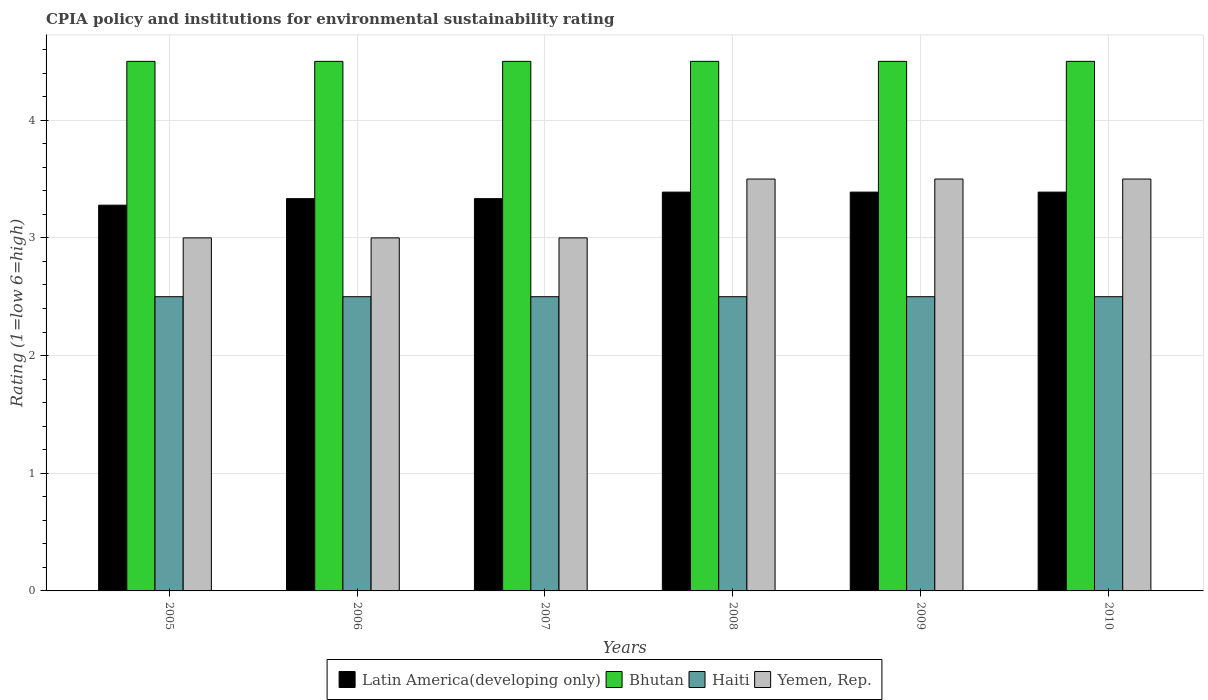How many groups of bars are there?
Provide a succinct answer. 6. Are the number of bars per tick equal to the number of legend labels?
Provide a succinct answer. Yes. Are the number of bars on each tick of the X-axis equal?
Your answer should be compact. Yes. How many bars are there on the 5th tick from the left?
Ensure brevity in your answer.  4. What is the label of the 6th group of bars from the left?
Ensure brevity in your answer.  2010. Across all years, what is the minimum CPIA rating in Latin America(developing only)?
Keep it short and to the point. 3.28. In which year was the CPIA rating in Haiti minimum?
Offer a terse response. 2005. What is the total CPIA rating in Latin America(developing only) in the graph?
Offer a very short reply. 20.11. What is the difference between the CPIA rating in Latin America(developing only) in 2005 and the CPIA rating in Bhutan in 2006?
Provide a short and direct response. -1.22. Is the CPIA rating in Yemen, Rep. in 2005 less than that in 2006?
Make the answer very short. No. Is the difference between the CPIA rating in Yemen, Rep. in 2006 and 2009 greater than the difference between the CPIA rating in Bhutan in 2006 and 2009?
Offer a terse response. No. What is the difference between the highest and the lowest CPIA rating in Latin America(developing only)?
Your answer should be compact. 0.11. Is the sum of the CPIA rating in Haiti in 2006 and 2009 greater than the maximum CPIA rating in Bhutan across all years?
Your response must be concise. Yes. Is it the case that in every year, the sum of the CPIA rating in Latin America(developing only) and CPIA rating in Bhutan is greater than the sum of CPIA rating in Yemen, Rep. and CPIA rating in Haiti?
Your answer should be very brief. No. What does the 2nd bar from the left in 2007 represents?
Provide a short and direct response. Bhutan. What does the 2nd bar from the right in 2010 represents?
Your response must be concise. Haiti. How many bars are there?
Ensure brevity in your answer.  24. How many years are there in the graph?
Give a very brief answer. 6. What is the difference between two consecutive major ticks on the Y-axis?
Provide a succinct answer. 1. Where does the legend appear in the graph?
Your response must be concise. Bottom center. How many legend labels are there?
Keep it short and to the point. 4. How are the legend labels stacked?
Make the answer very short. Horizontal. What is the title of the graph?
Make the answer very short. CPIA policy and institutions for environmental sustainability rating. What is the Rating (1=low 6=high) in Latin America(developing only) in 2005?
Give a very brief answer. 3.28. What is the Rating (1=low 6=high) of Yemen, Rep. in 2005?
Provide a short and direct response. 3. What is the Rating (1=low 6=high) in Latin America(developing only) in 2006?
Provide a short and direct response. 3.33. What is the Rating (1=low 6=high) of Haiti in 2006?
Your response must be concise. 2.5. What is the Rating (1=low 6=high) of Latin America(developing only) in 2007?
Keep it short and to the point. 3.33. What is the Rating (1=low 6=high) in Haiti in 2007?
Offer a very short reply. 2.5. What is the Rating (1=low 6=high) in Yemen, Rep. in 2007?
Your answer should be compact. 3. What is the Rating (1=low 6=high) of Latin America(developing only) in 2008?
Provide a succinct answer. 3.39. What is the Rating (1=low 6=high) in Bhutan in 2008?
Offer a terse response. 4.5. What is the Rating (1=low 6=high) of Latin America(developing only) in 2009?
Ensure brevity in your answer.  3.39. What is the Rating (1=low 6=high) in Latin America(developing only) in 2010?
Your response must be concise. 3.39. What is the Rating (1=low 6=high) in Bhutan in 2010?
Offer a very short reply. 4.5. Across all years, what is the maximum Rating (1=low 6=high) in Latin America(developing only)?
Your answer should be very brief. 3.39. Across all years, what is the minimum Rating (1=low 6=high) in Latin America(developing only)?
Keep it short and to the point. 3.28. Across all years, what is the minimum Rating (1=low 6=high) of Bhutan?
Offer a very short reply. 4.5. Across all years, what is the minimum Rating (1=low 6=high) of Haiti?
Provide a short and direct response. 2.5. What is the total Rating (1=low 6=high) of Latin America(developing only) in the graph?
Give a very brief answer. 20.11. What is the difference between the Rating (1=low 6=high) in Latin America(developing only) in 2005 and that in 2006?
Provide a succinct answer. -0.06. What is the difference between the Rating (1=low 6=high) in Latin America(developing only) in 2005 and that in 2007?
Ensure brevity in your answer.  -0.06. What is the difference between the Rating (1=low 6=high) of Bhutan in 2005 and that in 2007?
Offer a terse response. 0. What is the difference between the Rating (1=low 6=high) in Haiti in 2005 and that in 2007?
Your response must be concise. 0. What is the difference between the Rating (1=low 6=high) of Latin America(developing only) in 2005 and that in 2008?
Your answer should be compact. -0.11. What is the difference between the Rating (1=low 6=high) of Yemen, Rep. in 2005 and that in 2008?
Offer a terse response. -0.5. What is the difference between the Rating (1=low 6=high) in Latin America(developing only) in 2005 and that in 2009?
Your answer should be very brief. -0.11. What is the difference between the Rating (1=low 6=high) of Bhutan in 2005 and that in 2009?
Make the answer very short. 0. What is the difference between the Rating (1=low 6=high) of Haiti in 2005 and that in 2009?
Offer a very short reply. 0. What is the difference between the Rating (1=low 6=high) of Yemen, Rep. in 2005 and that in 2009?
Keep it short and to the point. -0.5. What is the difference between the Rating (1=low 6=high) of Latin America(developing only) in 2005 and that in 2010?
Your response must be concise. -0.11. What is the difference between the Rating (1=low 6=high) of Bhutan in 2005 and that in 2010?
Provide a succinct answer. 0. What is the difference between the Rating (1=low 6=high) in Yemen, Rep. in 2005 and that in 2010?
Provide a short and direct response. -0.5. What is the difference between the Rating (1=low 6=high) of Bhutan in 2006 and that in 2007?
Keep it short and to the point. 0. What is the difference between the Rating (1=low 6=high) of Yemen, Rep. in 2006 and that in 2007?
Provide a succinct answer. 0. What is the difference between the Rating (1=low 6=high) in Latin America(developing only) in 2006 and that in 2008?
Provide a succinct answer. -0.06. What is the difference between the Rating (1=low 6=high) of Yemen, Rep. in 2006 and that in 2008?
Offer a terse response. -0.5. What is the difference between the Rating (1=low 6=high) in Latin America(developing only) in 2006 and that in 2009?
Provide a short and direct response. -0.06. What is the difference between the Rating (1=low 6=high) of Bhutan in 2006 and that in 2009?
Your answer should be compact. 0. What is the difference between the Rating (1=low 6=high) of Haiti in 2006 and that in 2009?
Ensure brevity in your answer.  0. What is the difference between the Rating (1=low 6=high) of Yemen, Rep. in 2006 and that in 2009?
Offer a terse response. -0.5. What is the difference between the Rating (1=low 6=high) in Latin America(developing only) in 2006 and that in 2010?
Offer a very short reply. -0.06. What is the difference between the Rating (1=low 6=high) in Haiti in 2006 and that in 2010?
Your answer should be very brief. 0. What is the difference between the Rating (1=low 6=high) in Latin America(developing only) in 2007 and that in 2008?
Provide a succinct answer. -0.06. What is the difference between the Rating (1=low 6=high) of Bhutan in 2007 and that in 2008?
Provide a succinct answer. 0. What is the difference between the Rating (1=low 6=high) in Haiti in 2007 and that in 2008?
Keep it short and to the point. 0. What is the difference between the Rating (1=low 6=high) in Yemen, Rep. in 2007 and that in 2008?
Ensure brevity in your answer.  -0.5. What is the difference between the Rating (1=low 6=high) of Latin America(developing only) in 2007 and that in 2009?
Make the answer very short. -0.06. What is the difference between the Rating (1=low 6=high) in Haiti in 2007 and that in 2009?
Give a very brief answer. 0. What is the difference between the Rating (1=low 6=high) in Latin America(developing only) in 2007 and that in 2010?
Keep it short and to the point. -0.06. What is the difference between the Rating (1=low 6=high) in Bhutan in 2007 and that in 2010?
Your response must be concise. 0. What is the difference between the Rating (1=low 6=high) in Latin America(developing only) in 2008 and that in 2010?
Keep it short and to the point. 0. What is the difference between the Rating (1=low 6=high) of Bhutan in 2008 and that in 2010?
Provide a succinct answer. 0. What is the difference between the Rating (1=low 6=high) in Haiti in 2008 and that in 2010?
Keep it short and to the point. 0. What is the difference between the Rating (1=low 6=high) of Yemen, Rep. in 2008 and that in 2010?
Keep it short and to the point. 0. What is the difference between the Rating (1=low 6=high) in Latin America(developing only) in 2009 and that in 2010?
Your answer should be compact. 0. What is the difference between the Rating (1=low 6=high) in Haiti in 2009 and that in 2010?
Give a very brief answer. 0. What is the difference between the Rating (1=low 6=high) in Latin America(developing only) in 2005 and the Rating (1=low 6=high) in Bhutan in 2006?
Ensure brevity in your answer.  -1.22. What is the difference between the Rating (1=low 6=high) in Latin America(developing only) in 2005 and the Rating (1=low 6=high) in Haiti in 2006?
Give a very brief answer. 0.78. What is the difference between the Rating (1=low 6=high) in Latin America(developing only) in 2005 and the Rating (1=low 6=high) in Yemen, Rep. in 2006?
Make the answer very short. 0.28. What is the difference between the Rating (1=low 6=high) in Bhutan in 2005 and the Rating (1=low 6=high) in Haiti in 2006?
Your answer should be compact. 2. What is the difference between the Rating (1=low 6=high) in Haiti in 2005 and the Rating (1=low 6=high) in Yemen, Rep. in 2006?
Your answer should be compact. -0.5. What is the difference between the Rating (1=low 6=high) in Latin America(developing only) in 2005 and the Rating (1=low 6=high) in Bhutan in 2007?
Ensure brevity in your answer.  -1.22. What is the difference between the Rating (1=low 6=high) of Latin America(developing only) in 2005 and the Rating (1=low 6=high) of Haiti in 2007?
Your response must be concise. 0.78. What is the difference between the Rating (1=low 6=high) in Latin America(developing only) in 2005 and the Rating (1=low 6=high) in Yemen, Rep. in 2007?
Your answer should be compact. 0.28. What is the difference between the Rating (1=low 6=high) of Bhutan in 2005 and the Rating (1=low 6=high) of Haiti in 2007?
Provide a short and direct response. 2. What is the difference between the Rating (1=low 6=high) in Haiti in 2005 and the Rating (1=low 6=high) in Yemen, Rep. in 2007?
Your answer should be very brief. -0.5. What is the difference between the Rating (1=low 6=high) of Latin America(developing only) in 2005 and the Rating (1=low 6=high) of Bhutan in 2008?
Keep it short and to the point. -1.22. What is the difference between the Rating (1=low 6=high) in Latin America(developing only) in 2005 and the Rating (1=low 6=high) in Haiti in 2008?
Your answer should be very brief. 0.78. What is the difference between the Rating (1=low 6=high) in Latin America(developing only) in 2005 and the Rating (1=low 6=high) in Yemen, Rep. in 2008?
Your answer should be compact. -0.22. What is the difference between the Rating (1=low 6=high) in Bhutan in 2005 and the Rating (1=low 6=high) in Haiti in 2008?
Provide a short and direct response. 2. What is the difference between the Rating (1=low 6=high) in Latin America(developing only) in 2005 and the Rating (1=low 6=high) in Bhutan in 2009?
Ensure brevity in your answer.  -1.22. What is the difference between the Rating (1=low 6=high) of Latin America(developing only) in 2005 and the Rating (1=low 6=high) of Haiti in 2009?
Ensure brevity in your answer.  0.78. What is the difference between the Rating (1=low 6=high) of Latin America(developing only) in 2005 and the Rating (1=low 6=high) of Yemen, Rep. in 2009?
Your answer should be compact. -0.22. What is the difference between the Rating (1=low 6=high) in Bhutan in 2005 and the Rating (1=low 6=high) in Haiti in 2009?
Your answer should be compact. 2. What is the difference between the Rating (1=low 6=high) in Latin America(developing only) in 2005 and the Rating (1=low 6=high) in Bhutan in 2010?
Provide a succinct answer. -1.22. What is the difference between the Rating (1=low 6=high) in Latin America(developing only) in 2005 and the Rating (1=low 6=high) in Yemen, Rep. in 2010?
Ensure brevity in your answer.  -0.22. What is the difference between the Rating (1=low 6=high) of Bhutan in 2005 and the Rating (1=low 6=high) of Yemen, Rep. in 2010?
Make the answer very short. 1. What is the difference between the Rating (1=low 6=high) in Haiti in 2005 and the Rating (1=low 6=high) in Yemen, Rep. in 2010?
Offer a very short reply. -1. What is the difference between the Rating (1=low 6=high) in Latin America(developing only) in 2006 and the Rating (1=low 6=high) in Bhutan in 2007?
Your answer should be compact. -1.17. What is the difference between the Rating (1=low 6=high) in Latin America(developing only) in 2006 and the Rating (1=low 6=high) in Yemen, Rep. in 2007?
Make the answer very short. 0.33. What is the difference between the Rating (1=low 6=high) of Bhutan in 2006 and the Rating (1=low 6=high) of Haiti in 2007?
Your answer should be very brief. 2. What is the difference between the Rating (1=low 6=high) of Bhutan in 2006 and the Rating (1=low 6=high) of Yemen, Rep. in 2007?
Provide a short and direct response. 1.5. What is the difference between the Rating (1=low 6=high) of Haiti in 2006 and the Rating (1=low 6=high) of Yemen, Rep. in 2007?
Offer a very short reply. -0.5. What is the difference between the Rating (1=low 6=high) in Latin America(developing only) in 2006 and the Rating (1=low 6=high) in Bhutan in 2008?
Offer a terse response. -1.17. What is the difference between the Rating (1=low 6=high) of Latin America(developing only) in 2006 and the Rating (1=low 6=high) of Haiti in 2008?
Give a very brief answer. 0.83. What is the difference between the Rating (1=low 6=high) of Latin America(developing only) in 2006 and the Rating (1=low 6=high) of Yemen, Rep. in 2008?
Ensure brevity in your answer.  -0.17. What is the difference between the Rating (1=low 6=high) of Bhutan in 2006 and the Rating (1=low 6=high) of Yemen, Rep. in 2008?
Your answer should be compact. 1. What is the difference between the Rating (1=low 6=high) in Haiti in 2006 and the Rating (1=low 6=high) in Yemen, Rep. in 2008?
Offer a very short reply. -1. What is the difference between the Rating (1=low 6=high) in Latin America(developing only) in 2006 and the Rating (1=low 6=high) in Bhutan in 2009?
Make the answer very short. -1.17. What is the difference between the Rating (1=low 6=high) of Latin America(developing only) in 2006 and the Rating (1=low 6=high) of Yemen, Rep. in 2009?
Offer a very short reply. -0.17. What is the difference between the Rating (1=low 6=high) in Bhutan in 2006 and the Rating (1=low 6=high) in Haiti in 2009?
Provide a short and direct response. 2. What is the difference between the Rating (1=low 6=high) of Bhutan in 2006 and the Rating (1=low 6=high) of Yemen, Rep. in 2009?
Make the answer very short. 1. What is the difference between the Rating (1=low 6=high) in Latin America(developing only) in 2006 and the Rating (1=low 6=high) in Bhutan in 2010?
Offer a very short reply. -1.17. What is the difference between the Rating (1=low 6=high) in Latin America(developing only) in 2006 and the Rating (1=low 6=high) in Haiti in 2010?
Keep it short and to the point. 0.83. What is the difference between the Rating (1=low 6=high) of Latin America(developing only) in 2007 and the Rating (1=low 6=high) of Bhutan in 2008?
Make the answer very short. -1.17. What is the difference between the Rating (1=low 6=high) in Latin America(developing only) in 2007 and the Rating (1=low 6=high) in Yemen, Rep. in 2008?
Make the answer very short. -0.17. What is the difference between the Rating (1=low 6=high) of Haiti in 2007 and the Rating (1=low 6=high) of Yemen, Rep. in 2008?
Provide a succinct answer. -1. What is the difference between the Rating (1=low 6=high) in Latin America(developing only) in 2007 and the Rating (1=low 6=high) in Bhutan in 2009?
Your answer should be compact. -1.17. What is the difference between the Rating (1=low 6=high) in Latin America(developing only) in 2007 and the Rating (1=low 6=high) in Haiti in 2009?
Offer a very short reply. 0.83. What is the difference between the Rating (1=low 6=high) in Latin America(developing only) in 2007 and the Rating (1=low 6=high) in Yemen, Rep. in 2009?
Your answer should be very brief. -0.17. What is the difference between the Rating (1=low 6=high) of Bhutan in 2007 and the Rating (1=low 6=high) of Yemen, Rep. in 2009?
Ensure brevity in your answer.  1. What is the difference between the Rating (1=low 6=high) of Haiti in 2007 and the Rating (1=low 6=high) of Yemen, Rep. in 2009?
Your answer should be compact. -1. What is the difference between the Rating (1=low 6=high) in Latin America(developing only) in 2007 and the Rating (1=low 6=high) in Bhutan in 2010?
Provide a short and direct response. -1.17. What is the difference between the Rating (1=low 6=high) of Latin America(developing only) in 2007 and the Rating (1=low 6=high) of Haiti in 2010?
Offer a very short reply. 0.83. What is the difference between the Rating (1=low 6=high) in Latin America(developing only) in 2007 and the Rating (1=low 6=high) in Yemen, Rep. in 2010?
Ensure brevity in your answer.  -0.17. What is the difference between the Rating (1=low 6=high) in Bhutan in 2007 and the Rating (1=low 6=high) in Haiti in 2010?
Your answer should be very brief. 2. What is the difference between the Rating (1=low 6=high) of Latin America(developing only) in 2008 and the Rating (1=low 6=high) of Bhutan in 2009?
Offer a very short reply. -1.11. What is the difference between the Rating (1=low 6=high) in Latin America(developing only) in 2008 and the Rating (1=low 6=high) in Haiti in 2009?
Make the answer very short. 0.89. What is the difference between the Rating (1=low 6=high) in Latin America(developing only) in 2008 and the Rating (1=low 6=high) in Yemen, Rep. in 2009?
Make the answer very short. -0.11. What is the difference between the Rating (1=low 6=high) in Bhutan in 2008 and the Rating (1=low 6=high) in Haiti in 2009?
Ensure brevity in your answer.  2. What is the difference between the Rating (1=low 6=high) of Latin America(developing only) in 2008 and the Rating (1=low 6=high) of Bhutan in 2010?
Provide a succinct answer. -1.11. What is the difference between the Rating (1=low 6=high) in Latin America(developing only) in 2008 and the Rating (1=low 6=high) in Yemen, Rep. in 2010?
Your answer should be compact. -0.11. What is the difference between the Rating (1=low 6=high) in Bhutan in 2008 and the Rating (1=low 6=high) in Haiti in 2010?
Give a very brief answer. 2. What is the difference between the Rating (1=low 6=high) in Bhutan in 2008 and the Rating (1=low 6=high) in Yemen, Rep. in 2010?
Ensure brevity in your answer.  1. What is the difference between the Rating (1=low 6=high) of Haiti in 2008 and the Rating (1=low 6=high) of Yemen, Rep. in 2010?
Offer a very short reply. -1. What is the difference between the Rating (1=low 6=high) of Latin America(developing only) in 2009 and the Rating (1=low 6=high) of Bhutan in 2010?
Your answer should be compact. -1.11. What is the difference between the Rating (1=low 6=high) in Latin America(developing only) in 2009 and the Rating (1=low 6=high) in Haiti in 2010?
Your answer should be very brief. 0.89. What is the difference between the Rating (1=low 6=high) in Latin America(developing only) in 2009 and the Rating (1=low 6=high) in Yemen, Rep. in 2010?
Your response must be concise. -0.11. What is the difference between the Rating (1=low 6=high) in Bhutan in 2009 and the Rating (1=low 6=high) in Haiti in 2010?
Give a very brief answer. 2. What is the difference between the Rating (1=low 6=high) of Bhutan in 2009 and the Rating (1=low 6=high) of Yemen, Rep. in 2010?
Offer a terse response. 1. What is the average Rating (1=low 6=high) in Latin America(developing only) per year?
Keep it short and to the point. 3.35. What is the average Rating (1=low 6=high) in Yemen, Rep. per year?
Offer a very short reply. 3.25. In the year 2005, what is the difference between the Rating (1=low 6=high) of Latin America(developing only) and Rating (1=low 6=high) of Bhutan?
Ensure brevity in your answer.  -1.22. In the year 2005, what is the difference between the Rating (1=low 6=high) in Latin America(developing only) and Rating (1=low 6=high) in Haiti?
Your response must be concise. 0.78. In the year 2005, what is the difference between the Rating (1=low 6=high) in Latin America(developing only) and Rating (1=low 6=high) in Yemen, Rep.?
Your answer should be compact. 0.28. In the year 2005, what is the difference between the Rating (1=low 6=high) of Bhutan and Rating (1=low 6=high) of Haiti?
Offer a very short reply. 2. In the year 2005, what is the difference between the Rating (1=low 6=high) of Bhutan and Rating (1=low 6=high) of Yemen, Rep.?
Keep it short and to the point. 1.5. In the year 2006, what is the difference between the Rating (1=low 6=high) of Latin America(developing only) and Rating (1=low 6=high) of Bhutan?
Your response must be concise. -1.17. In the year 2006, what is the difference between the Rating (1=low 6=high) of Latin America(developing only) and Rating (1=low 6=high) of Haiti?
Make the answer very short. 0.83. In the year 2006, what is the difference between the Rating (1=low 6=high) in Bhutan and Rating (1=low 6=high) in Yemen, Rep.?
Keep it short and to the point. 1.5. In the year 2007, what is the difference between the Rating (1=low 6=high) of Latin America(developing only) and Rating (1=low 6=high) of Bhutan?
Offer a terse response. -1.17. In the year 2007, what is the difference between the Rating (1=low 6=high) in Bhutan and Rating (1=low 6=high) in Yemen, Rep.?
Make the answer very short. 1.5. In the year 2008, what is the difference between the Rating (1=low 6=high) in Latin America(developing only) and Rating (1=low 6=high) in Bhutan?
Provide a succinct answer. -1.11. In the year 2008, what is the difference between the Rating (1=low 6=high) of Latin America(developing only) and Rating (1=low 6=high) of Haiti?
Your answer should be compact. 0.89. In the year 2008, what is the difference between the Rating (1=low 6=high) of Latin America(developing only) and Rating (1=low 6=high) of Yemen, Rep.?
Make the answer very short. -0.11. In the year 2008, what is the difference between the Rating (1=low 6=high) of Bhutan and Rating (1=low 6=high) of Haiti?
Make the answer very short. 2. In the year 2008, what is the difference between the Rating (1=low 6=high) in Haiti and Rating (1=low 6=high) in Yemen, Rep.?
Make the answer very short. -1. In the year 2009, what is the difference between the Rating (1=low 6=high) in Latin America(developing only) and Rating (1=low 6=high) in Bhutan?
Provide a short and direct response. -1.11. In the year 2009, what is the difference between the Rating (1=low 6=high) in Latin America(developing only) and Rating (1=low 6=high) in Haiti?
Offer a terse response. 0.89. In the year 2009, what is the difference between the Rating (1=low 6=high) of Latin America(developing only) and Rating (1=low 6=high) of Yemen, Rep.?
Offer a terse response. -0.11. In the year 2009, what is the difference between the Rating (1=low 6=high) in Bhutan and Rating (1=low 6=high) in Haiti?
Give a very brief answer. 2. In the year 2009, what is the difference between the Rating (1=low 6=high) of Bhutan and Rating (1=low 6=high) of Yemen, Rep.?
Provide a short and direct response. 1. In the year 2009, what is the difference between the Rating (1=low 6=high) of Haiti and Rating (1=low 6=high) of Yemen, Rep.?
Provide a short and direct response. -1. In the year 2010, what is the difference between the Rating (1=low 6=high) of Latin America(developing only) and Rating (1=low 6=high) of Bhutan?
Your answer should be compact. -1.11. In the year 2010, what is the difference between the Rating (1=low 6=high) in Latin America(developing only) and Rating (1=low 6=high) in Haiti?
Your answer should be compact. 0.89. In the year 2010, what is the difference between the Rating (1=low 6=high) of Latin America(developing only) and Rating (1=low 6=high) of Yemen, Rep.?
Make the answer very short. -0.11. In the year 2010, what is the difference between the Rating (1=low 6=high) of Bhutan and Rating (1=low 6=high) of Yemen, Rep.?
Ensure brevity in your answer.  1. What is the ratio of the Rating (1=low 6=high) of Latin America(developing only) in 2005 to that in 2006?
Your response must be concise. 0.98. What is the ratio of the Rating (1=low 6=high) of Latin America(developing only) in 2005 to that in 2007?
Ensure brevity in your answer.  0.98. What is the ratio of the Rating (1=low 6=high) in Bhutan in 2005 to that in 2007?
Make the answer very short. 1. What is the ratio of the Rating (1=low 6=high) of Haiti in 2005 to that in 2007?
Keep it short and to the point. 1. What is the ratio of the Rating (1=low 6=high) of Latin America(developing only) in 2005 to that in 2008?
Offer a very short reply. 0.97. What is the ratio of the Rating (1=low 6=high) in Haiti in 2005 to that in 2008?
Provide a succinct answer. 1. What is the ratio of the Rating (1=low 6=high) in Latin America(developing only) in 2005 to that in 2009?
Make the answer very short. 0.97. What is the ratio of the Rating (1=low 6=high) of Haiti in 2005 to that in 2009?
Ensure brevity in your answer.  1. What is the ratio of the Rating (1=low 6=high) in Latin America(developing only) in 2005 to that in 2010?
Your response must be concise. 0.97. What is the ratio of the Rating (1=low 6=high) of Bhutan in 2005 to that in 2010?
Offer a very short reply. 1. What is the ratio of the Rating (1=low 6=high) in Bhutan in 2006 to that in 2007?
Your response must be concise. 1. What is the ratio of the Rating (1=low 6=high) in Haiti in 2006 to that in 2007?
Ensure brevity in your answer.  1. What is the ratio of the Rating (1=low 6=high) in Latin America(developing only) in 2006 to that in 2008?
Offer a terse response. 0.98. What is the ratio of the Rating (1=low 6=high) in Bhutan in 2006 to that in 2008?
Make the answer very short. 1. What is the ratio of the Rating (1=low 6=high) in Latin America(developing only) in 2006 to that in 2009?
Provide a succinct answer. 0.98. What is the ratio of the Rating (1=low 6=high) in Haiti in 2006 to that in 2009?
Your answer should be compact. 1. What is the ratio of the Rating (1=low 6=high) in Latin America(developing only) in 2006 to that in 2010?
Your response must be concise. 0.98. What is the ratio of the Rating (1=low 6=high) in Latin America(developing only) in 2007 to that in 2008?
Offer a very short reply. 0.98. What is the ratio of the Rating (1=low 6=high) of Bhutan in 2007 to that in 2008?
Ensure brevity in your answer.  1. What is the ratio of the Rating (1=low 6=high) in Yemen, Rep. in 2007 to that in 2008?
Your answer should be very brief. 0.86. What is the ratio of the Rating (1=low 6=high) of Latin America(developing only) in 2007 to that in 2009?
Keep it short and to the point. 0.98. What is the ratio of the Rating (1=low 6=high) of Latin America(developing only) in 2007 to that in 2010?
Your answer should be compact. 0.98. What is the ratio of the Rating (1=low 6=high) in Bhutan in 2007 to that in 2010?
Provide a succinct answer. 1. What is the ratio of the Rating (1=low 6=high) of Haiti in 2007 to that in 2010?
Offer a terse response. 1. What is the ratio of the Rating (1=low 6=high) of Latin America(developing only) in 2008 to that in 2009?
Your answer should be compact. 1. What is the ratio of the Rating (1=low 6=high) of Haiti in 2008 to that in 2009?
Your answer should be very brief. 1. What is the ratio of the Rating (1=low 6=high) of Yemen, Rep. in 2008 to that in 2009?
Keep it short and to the point. 1. What is the ratio of the Rating (1=low 6=high) in Yemen, Rep. in 2008 to that in 2010?
Provide a succinct answer. 1. What is the ratio of the Rating (1=low 6=high) of Latin America(developing only) in 2009 to that in 2010?
Your answer should be compact. 1. What is the ratio of the Rating (1=low 6=high) of Yemen, Rep. in 2009 to that in 2010?
Make the answer very short. 1. What is the difference between the highest and the second highest Rating (1=low 6=high) in Latin America(developing only)?
Make the answer very short. 0. What is the difference between the highest and the second highest Rating (1=low 6=high) in Bhutan?
Ensure brevity in your answer.  0. What is the difference between the highest and the second highest Rating (1=low 6=high) in Haiti?
Your answer should be very brief. 0. 